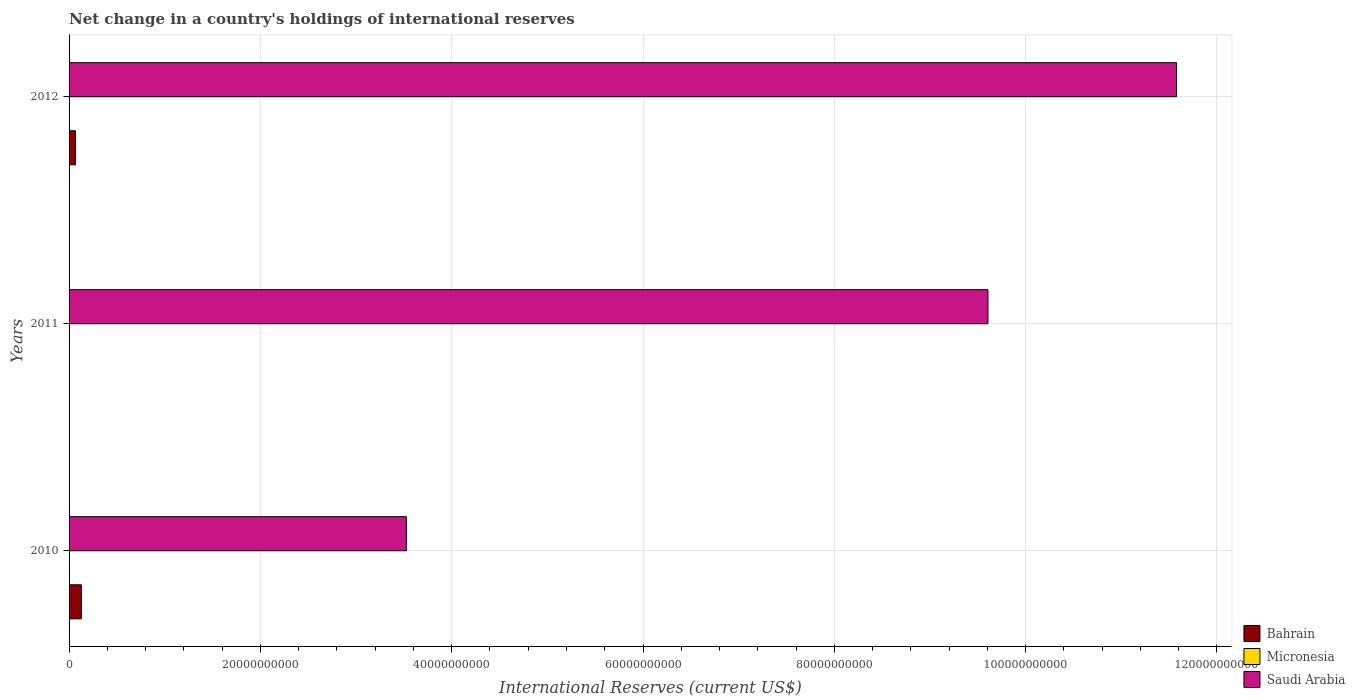How many groups of bars are there?
Keep it short and to the point. 3. Are the number of bars per tick equal to the number of legend labels?
Provide a short and direct response. No. How many bars are there on the 1st tick from the top?
Give a very brief answer. 3. How many bars are there on the 2nd tick from the bottom?
Provide a short and direct response. 2. What is the international reserves in Micronesia in 2011?
Make the answer very short. 2.51e+07. Across all years, what is the maximum international reserves in Micronesia?
Make the answer very short. 2.51e+07. Across all years, what is the minimum international reserves in Micronesia?
Ensure brevity in your answer.  4.65e+06. What is the total international reserves in Saudi Arabia in the graph?
Offer a terse response. 2.47e+11. What is the difference between the international reserves in Micronesia in 2011 and that in 2012?
Provide a short and direct response. 2.01e+07. What is the difference between the international reserves in Micronesia in 2010 and the international reserves in Bahrain in 2012?
Give a very brief answer. -6.68e+08. What is the average international reserves in Bahrain per year?
Ensure brevity in your answer.  6.51e+08. In the year 2012, what is the difference between the international reserves in Bahrain and international reserves in Micronesia?
Make the answer very short. 6.68e+08. In how many years, is the international reserves in Micronesia greater than 116000000000 US$?
Your response must be concise. 0. What is the ratio of the international reserves in Saudi Arabia in 2010 to that in 2012?
Offer a terse response. 0.3. What is the difference between the highest and the second highest international reserves in Micronesia?
Provide a short and direct response. 2.01e+07. What is the difference between the highest and the lowest international reserves in Saudi Arabia?
Your response must be concise. 8.05e+1. In how many years, is the international reserves in Micronesia greater than the average international reserves in Micronesia taken over all years?
Ensure brevity in your answer.  1. Is the sum of the international reserves in Saudi Arabia in 2011 and 2012 greater than the maximum international reserves in Micronesia across all years?
Make the answer very short. Yes. Is it the case that in every year, the sum of the international reserves in Micronesia and international reserves in Saudi Arabia is greater than the international reserves in Bahrain?
Ensure brevity in your answer.  Yes. Are all the bars in the graph horizontal?
Offer a terse response. Yes. How many years are there in the graph?
Provide a short and direct response. 3. What is the difference between two consecutive major ticks on the X-axis?
Your response must be concise. 2.00e+1. Are the values on the major ticks of X-axis written in scientific E-notation?
Keep it short and to the point. No. What is the title of the graph?
Make the answer very short. Net change in a country's holdings of international reserves. Does "Sierra Leone" appear as one of the legend labels in the graph?
Make the answer very short. No. What is the label or title of the X-axis?
Provide a short and direct response. International Reserves (current US$). What is the label or title of the Y-axis?
Make the answer very short. Years. What is the International Reserves (current US$) in Bahrain in 2010?
Your answer should be compact. 1.28e+09. What is the International Reserves (current US$) of Micronesia in 2010?
Your answer should be compact. 4.65e+06. What is the International Reserves (current US$) of Saudi Arabia in 2010?
Ensure brevity in your answer.  3.53e+1. What is the International Reserves (current US$) in Micronesia in 2011?
Your answer should be very brief. 2.51e+07. What is the International Reserves (current US$) of Saudi Arabia in 2011?
Keep it short and to the point. 9.61e+1. What is the International Reserves (current US$) of Bahrain in 2012?
Offer a terse response. 6.73e+08. What is the International Reserves (current US$) in Micronesia in 2012?
Your answer should be very brief. 5.02e+06. What is the International Reserves (current US$) in Saudi Arabia in 2012?
Your answer should be very brief. 1.16e+11. Across all years, what is the maximum International Reserves (current US$) in Bahrain?
Offer a terse response. 1.28e+09. Across all years, what is the maximum International Reserves (current US$) in Micronesia?
Ensure brevity in your answer.  2.51e+07. Across all years, what is the maximum International Reserves (current US$) in Saudi Arabia?
Your response must be concise. 1.16e+11. Across all years, what is the minimum International Reserves (current US$) of Micronesia?
Your response must be concise. 4.65e+06. Across all years, what is the minimum International Reserves (current US$) of Saudi Arabia?
Give a very brief answer. 3.53e+1. What is the total International Reserves (current US$) of Bahrain in the graph?
Offer a terse response. 1.95e+09. What is the total International Reserves (current US$) of Micronesia in the graph?
Make the answer very short. 3.48e+07. What is the total International Reserves (current US$) of Saudi Arabia in the graph?
Ensure brevity in your answer.  2.47e+11. What is the difference between the International Reserves (current US$) of Micronesia in 2010 and that in 2011?
Offer a very short reply. -2.05e+07. What is the difference between the International Reserves (current US$) of Saudi Arabia in 2010 and that in 2011?
Give a very brief answer. -6.08e+1. What is the difference between the International Reserves (current US$) of Bahrain in 2010 and that in 2012?
Provide a succinct answer. 6.07e+08. What is the difference between the International Reserves (current US$) in Micronesia in 2010 and that in 2012?
Offer a very short reply. -3.69e+05. What is the difference between the International Reserves (current US$) in Saudi Arabia in 2010 and that in 2012?
Your response must be concise. -8.05e+1. What is the difference between the International Reserves (current US$) of Micronesia in 2011 and that in 2012?
Provide a succinct answer. 2.01e+07. What is the difference between the International Reserves (current US$) in Saudi Arabia in 2011 and that in 2012?
Offer a terse response. -1.97e+1. What is the difference between the International Reserves (current US$) in Bahrain in 2010 and the International Reserves (current US$) in Micronesia in 2011?
Make the answer very short. 1.25e+09. What is the difference between the International Reserves (current US$) of Bahrain in 2010 and the International Reserves (current US$) of Saudi Arabia in 2011?
Offer a terse response. -9.48e+1. What is the difference between the International Reserves (current US$) of Micronesia in 2010 and the International Reserves (current US$) of Saudi Arabia in 2011?
Your response must be concise. -9.61e+1. What is the difference between the International Reserves (current US$) of Bahrain in 2010 and the International Reserves (current US$) of Micronesia in 2012?
Offer a very short reply. 1.27e+09. What is the difference between the International Reserves (current US$) of Bahrain in 2010 and the International Reserves (current US$) of Saudi Arabia in 2012?
Make the answer very short. -1.14e+11. What is the difference between the International Reserves (current US$) of Micronesia in 2010 and the International Reserves (current US$) of Saudi Arabia in 2012?
Offer a terse response. -1.16e+11. What is the difference between the International Reserves (current US$) of Micronesia in 2011 and the International Reserves (current US$) of Saudi Arabia in 2012?
Your answer should be very brief. -1.16e+11. What is the average International Reserves (current US$) in Bahrain per year?
Ensure brevity in your answer.  6.51e+08. What is the average International Reserves (current US$) in Micronesia per year?
Provide a short and direct response. 1.16e+07. What is the average International Reserves (current US$) of Saudi Arabia per year?
Give a very brief answer. 8.24e+1. In the year 2010, what is the difference between the International Reserves (current US$) of Bahrain and International Reserves (current US$) of Micronesia?
Your answer should be very brief. 1.27e+09. In the year 2010, what is the difference between the International Reserves (current US$) in Bahrain and International Reserves (current US$) in Saudi Arabia?
Provide a short and direct response. -3.40e+1. In the year 2010, what is the difference between the International Reserves (current US$) in Micronesia and International Reserves (current US$) in Saudi Arabia?
Give a very brief answer. -3.53e+1. In the year 2011, what is the difference between the International Reserves (current US$) in Micronesia and International Reserves (current US$) in Saudi Arabia?
Your answer should be very brief. -9.60e+1. In the year 2012, what is the difference between the International Reserves (current US$) of Bahrain and International Reserves (current US$) of Micronesia?
Offer a very short reply. 6.68e+08. In the year 2012, what is the difference between the International Reserves (current US$) in Bahrain and International Reserves (current US$) in Saudi Arabia?
Offer a terse response. -1.15e+11. In the year 2012, what is the difference between the International Reserves (current US$) of Micronesia and International Reserves (current US$) of Saudi Arabia?
Offer a terse response. -1.16e+11. What is the ratio of the International Reserves (current US$) in Micronesia in 2010 to that in 2011?
Offer a terse response. 0.18. What is the ratio of the International Reserves (current US$) in Saudi Arabia in 2010 to that in 2011?
Your response must be concise. 0.37. What is the ratio of the International Reserves (current US$) of Bahrain in 2010 to that in 2012?
Your answer should be very brief. 1.9. What is the ratio of the International Reserves (current US$) in Micronesia in 2010 to that in 2012?
Your answer should be compact. 0.93. What is the ratio of the International Reserves (current US$) in Saudi Arabia in 2010 to that in 2012?
Provide a succinct answer. 0.3. What is the ratio of the International Reserves (current US$) in Micronesia in 2011 to that in 2012?
Ensure brevity in your answer.  5.01. What is the ratio of the International Reserves (current US$) of Saudi Arabia in 2011 to that in 2012?
Offer a very short reply. 0.83. What is the difference between the highest and the second highest International Reserves (current US$) of Micronesia?
Offer a terse response. 2.01e+07. What is the difference between the highest and the second highest International Reserves (current US$) of Saudi Arabia?
Offer a very short reply. 1.97e+1. What is the difference between the highest and the lowest International Reserves (current US$) of Bahrain?
Your response must be concise. 1.28e+09. What is the difference between the highest and the lowest International Reserves (current US$) in Micronesia?
Make the answer very short. 2.05e+07. What is the difference between the highest and the lowest International Reserves (current US$) in Saudi Arabia?
Offer a terse response. 8.05e+1. 